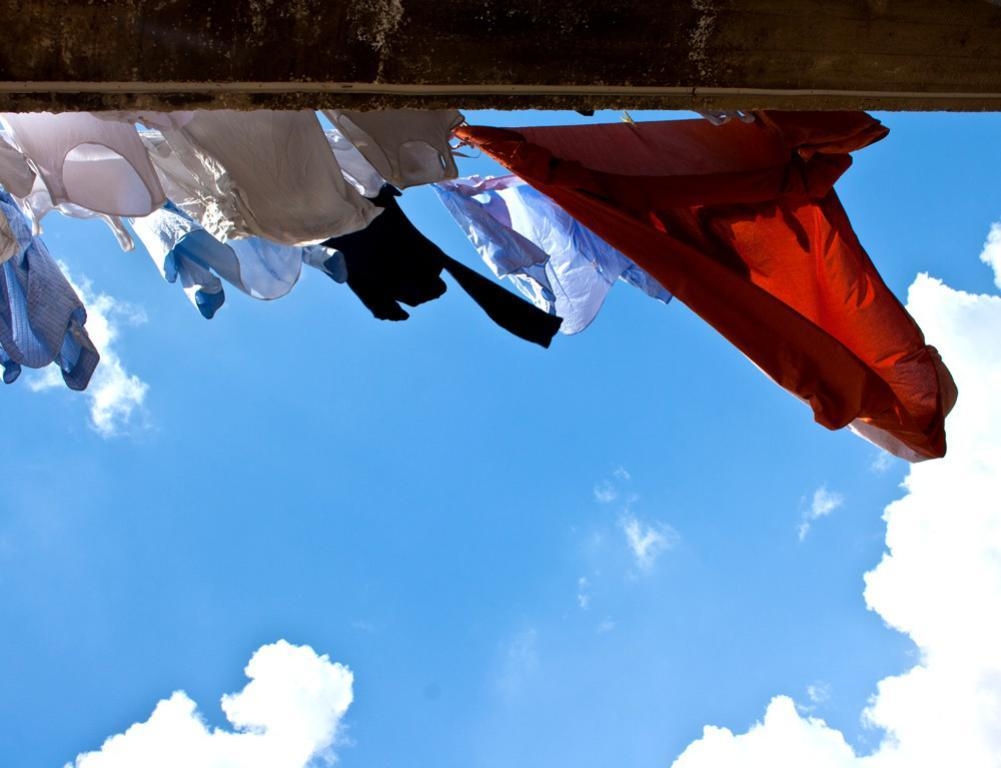What is hanging on the rope in the image? There are clothes hanging on a rope in the image. What type of material is the wall above the clothes made of? The wall above the clothes is made of wood. What is visible at the bottom of the image? The sky is visible at the bottom of the image. What sense is being used to detect the secretary in the image? There is no secretary present in the image, so it is not possible to detect one using any sense. 